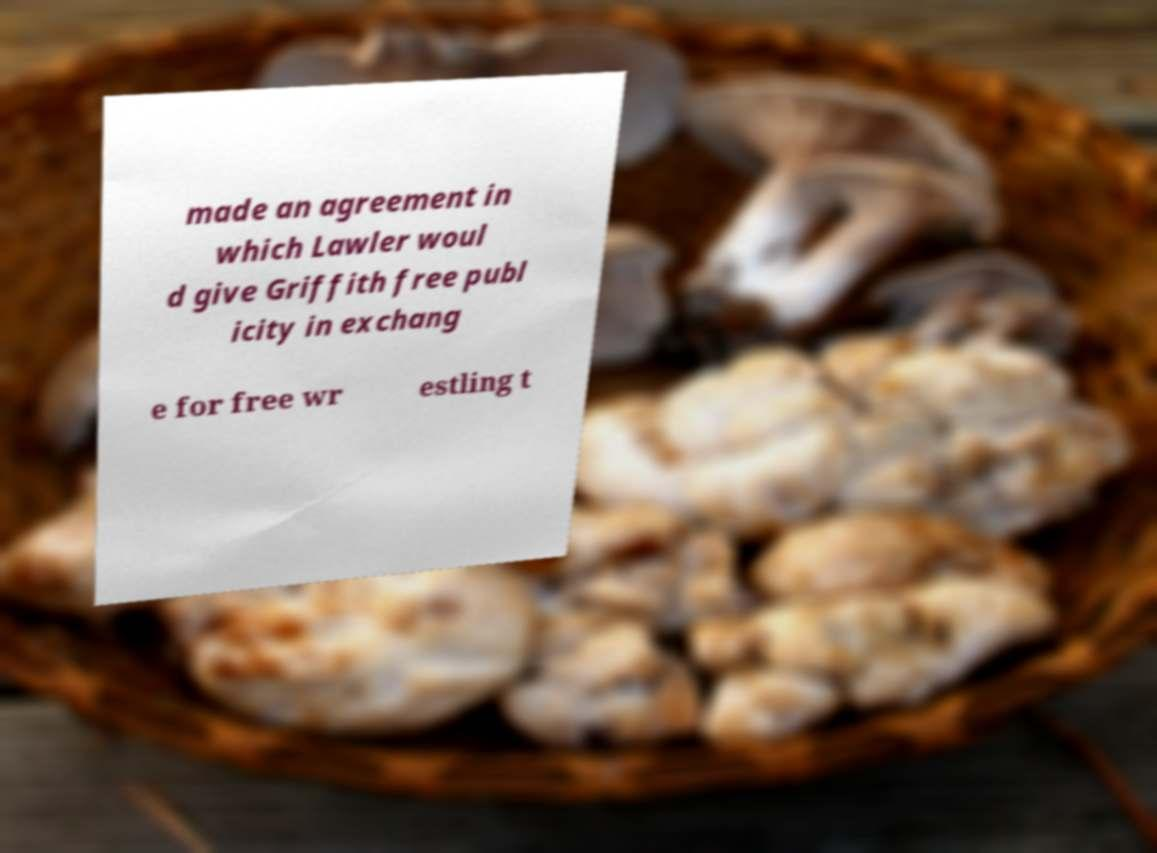Please identify and transcribe the text found in this image. made an agreement in which Lawler woul d give Griffith free publ icity in exchang e for free wr estling t 